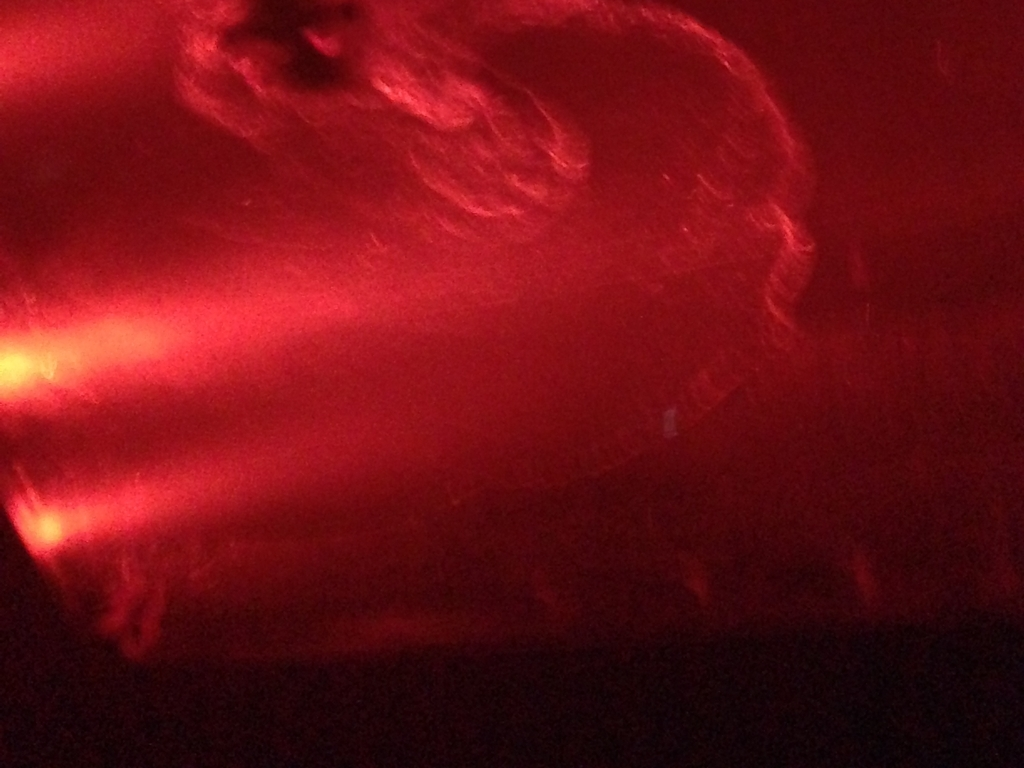Could this image be part of a specific event or setting that explains its current quality and colors? Given the intense red hue and blurred details, this image might have been taken at a concert or a similar low-light event where red lighting is common. The blurring could indicate movement, either of the camera or within the scene, suggesting active participation in the event such as dancing or movement of the crowd. 